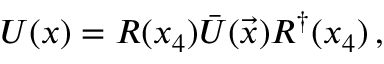Convert formula to latex. <formula><loc_0><loc_0><loc_500><loc_500>U ( x ) = R ( x _ { 4 } ) \bar { U } ( { \vec { x } } ) R ^ { \dagger } ( x _ { 4 } ) \, ,</formula> 